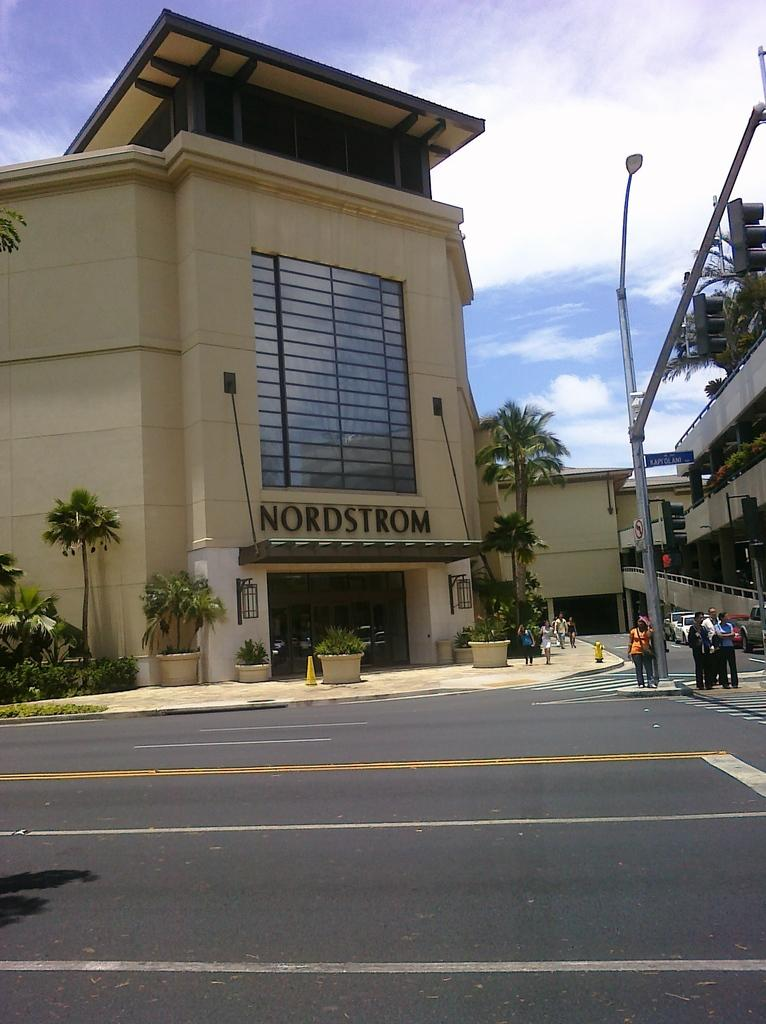Provide a one-sentence caption for the provided image. Nordstrom building at a mall with people standing in front. 